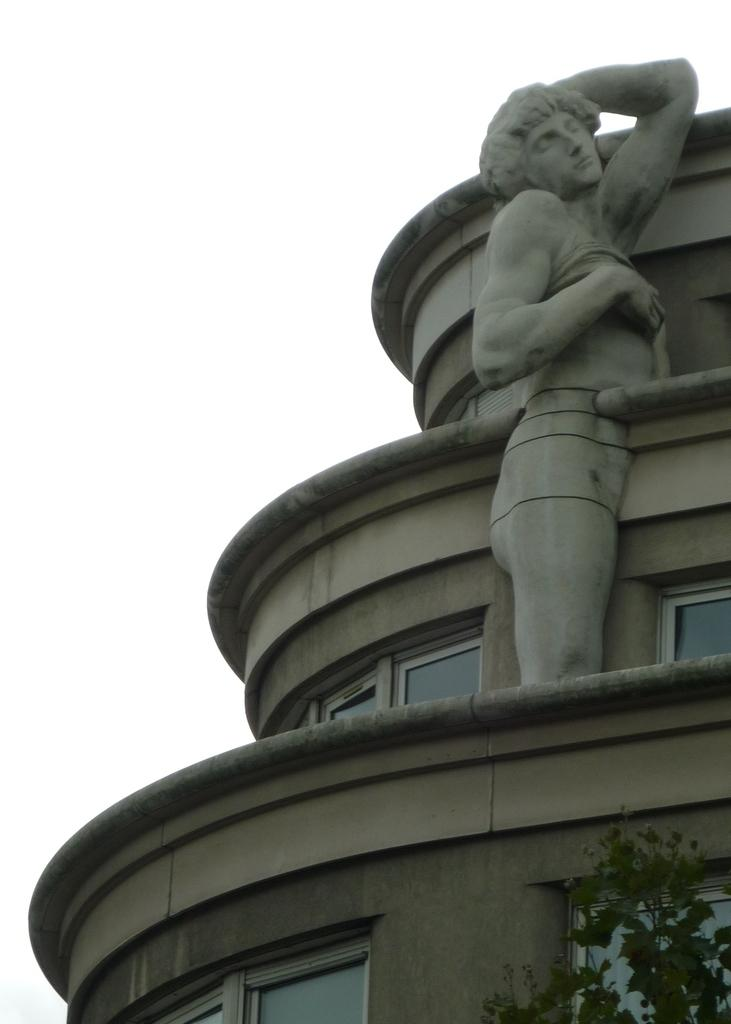What type of structure can be seen on the building in the image? There is a human structure, such as a statue or sculpture, on the building. What natural element is present in the bottom right of the image? There is a tree on the bottom right of the image. What type of tax is being discussed in the image? There is no discussion of tax in the image; it features a human structure on a building and a tree. What type of wine is being served in the image? There is no wine present in the image. 